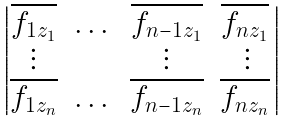Convert formula to latex. <formula><loc_0><loc_0><loc_500><loc_500>\begin{vmatrix} \overline { f _ { 1 z _ { 1 } } } & \dots & \overline { f _ { n - 1 z _ { 1 } } } & \overline { f _ { n z _ { 1 } } } \, \\ \vdots & & \vdots & \vdots \\ \overline { f _ { 1 z _ { n } } } & \dots & \overline { f _ { n - 1 z _ { n } } } & \overline { f _ { n z _ { n } } } \, \end{vmatrix}</formula> 